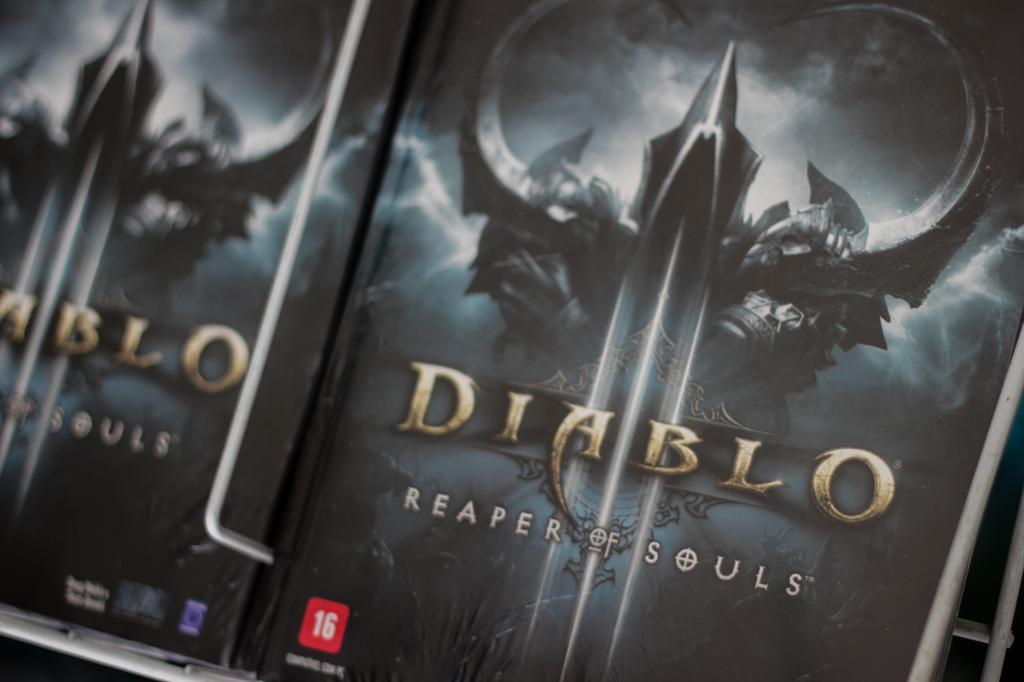What number is in the red square?
Offer a terse response. 16. 